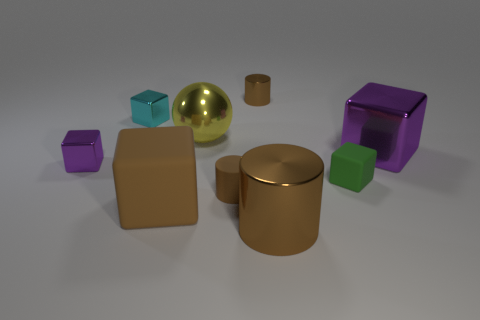Are there more matte blocks than cubes? Upon reviewing the image, it appears that there is an equal number of matte blocks and cubes. There are three matte objects: two cylinders and one sphere, and three cubes with a shiny surface finish. 